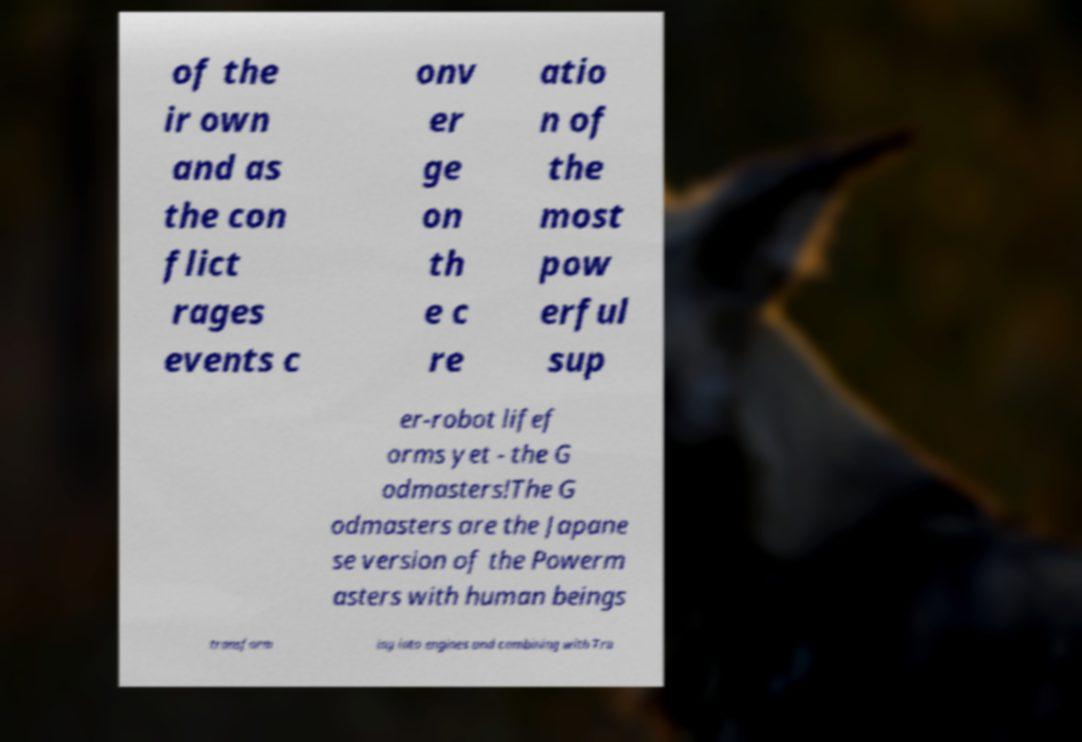What messages or text are displayed in this image? I need them in a readable, typed format. of the ir own and as the con flict rages events c onv er ge on th e c re atio n of the most pow erful sup er-robot lifef orms yet - the G odmasters!The G odmasters are the Japane se version of the Powerm asters with human beings transform ing into engines and combining with Tra 